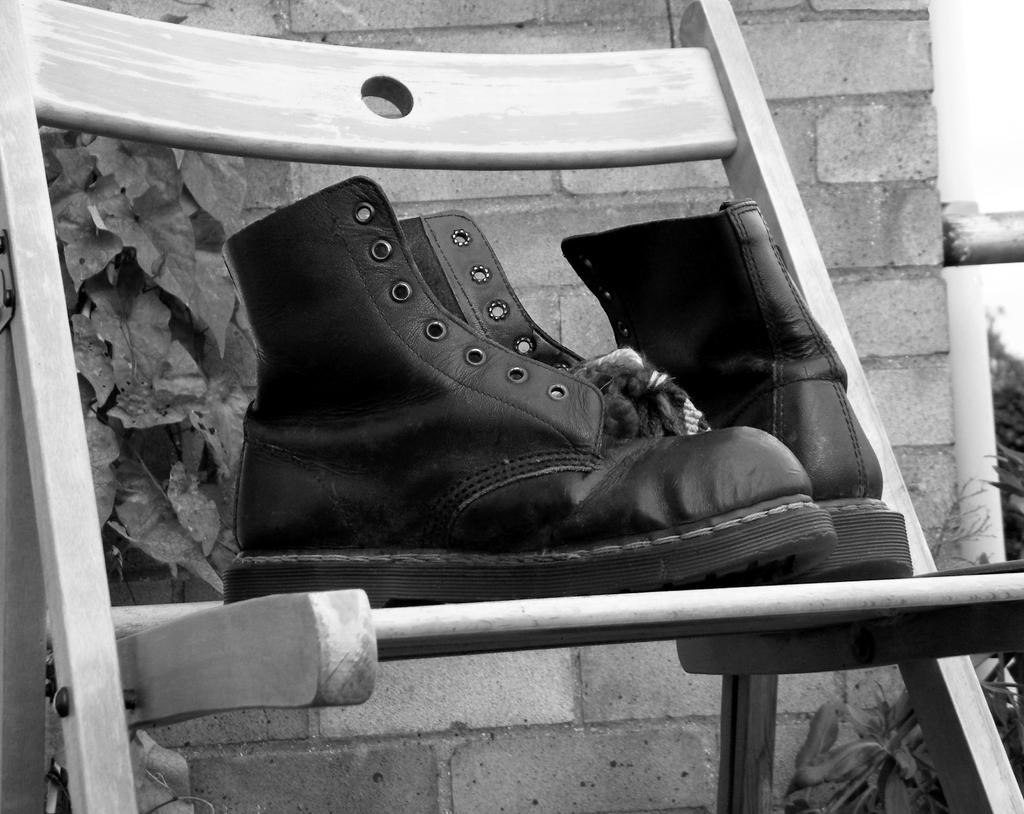What is the color scheme of the image? The image is black and white. What can be seen on the chair in the image? There are shoes on a chair in the image. Where is the chair located in relation to the wall? The chair is in front of a wall in the image. What is present on the left side of the image? There is a plant on the left side of the image. What is the daughter doing in the image? There is no mention of a daughter in the image or the provided facts. 